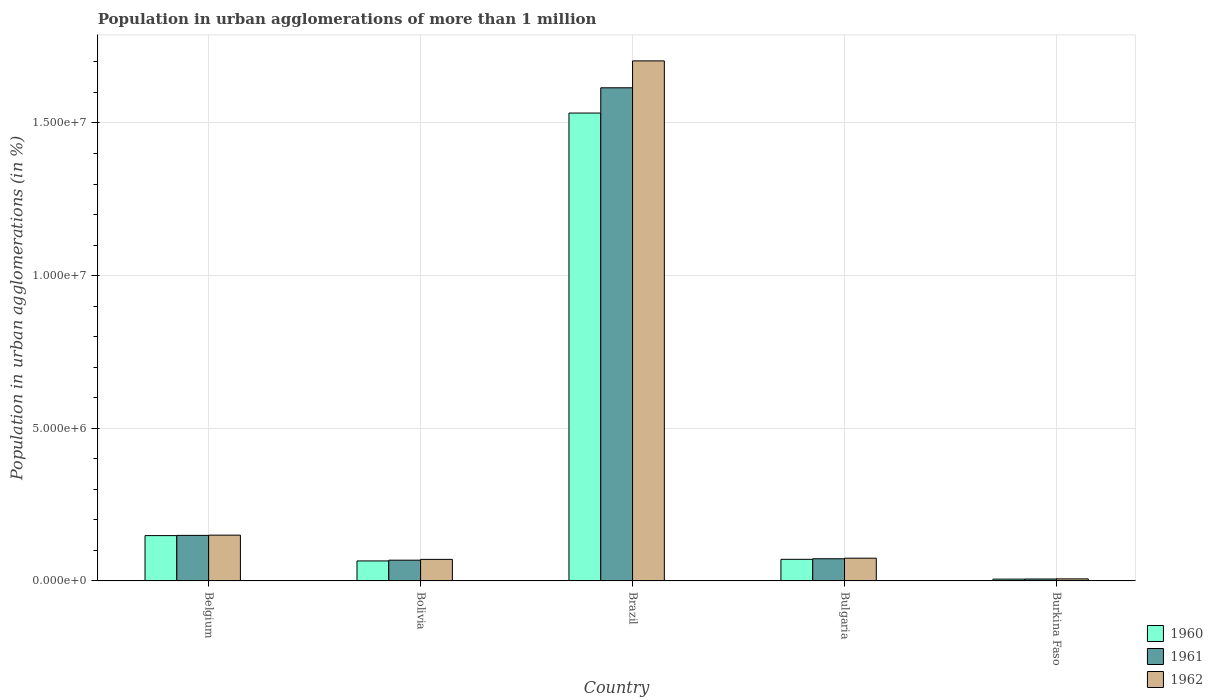How many groups of bars are there?
Ensure brevity in your answer.  5. How many bars are there on the 2nd tick from the right?
Your response must be concise. 3. What is the label of the 2nd group of bars from the left?
Keep it short and to the point. Bolivia. What is the population in urban agglomerations in 1962 in Bolivia?
Keep it short and to the point. 7.06e+05. Across all countries, what is the maximum population in urban agglomerations in 1962?
Offer a terse response. 1.70e+07. Across all countries, what is the minimum population in urban agglomerations in 1961?
Offer a terse response. 6.31e+04. In which country was the population in urban agglomerations in 1960 maximum?
Your response must be concise. Brazil. In which country was the population in urban agglomerations in 1961 minimum?
Provide a succinct answer. Burkina Faso. What is the total population in urban agglomerations in 1961 in the graph?
Offer a very short reply. 1.91e+07. What is the difference between the population in urban agglomerations in 1961 in Belgium and that in Bolivia?
Ensure brevity in your answer.  8.12e+05. What is the difference between the population in urban agglomerations in 1962 in Burkina Faso and the population in urban agglomerations in 1961 in Brazil?
Offer a terse response. -1.61e+07. What is the average population in urban agglomerations in 1960 per country?
Offer a terse response. 3.65e+06. What is the difference between the population in urban agglomerations of/in 1962 and population in urban agglomerations of/in 1960 in Brazil?
Your answer should be compact. 1.71e+06. In how many countries, is the population in urban agglomerations in 1961 greater than 10000000 %?
Provide a short and direct response. 1. What is the ratio of the population in urban agglomerations in 1960 in Belgium to that in Bulgaria?
Provide a short and direct response. 2.1. Is the difference between the population in urban agglomerations in 1962 in Belgium and Bulgaria greater than the difference between the population in urban agglomerations in 1960 in Belgium and Bulgaria?
Provide a succinct answer. No. What is the difference between the highest and the second highest population in urban agglomerations in 1961?
Make the answer very short. -1.54e+07. What is the difference between the highest and the lowest population in urban agglomerations in 1962?
Make the answer very short. 1.70e+07. Is the sum of the population in urban agglomerations in 1960 in Brazil and Bulgaria greater than the maximum population in urban agglomerations in 1962 across all countries?
Offer a terse response. No. How many bars are there?
Your answer should be very brief. 15. Are all the bars in the graph horizontal?
Your answer should be very brief. No. What is the difference between two consecutive major ticks on the Y-axis?
Your answer should be very brief. 5.00e+06. Does the graph contain any zero values?
Give a very brief answer. No. Does the graph contain grids?
Your response must be concise. Yes. What is the title of the graph?
Your answer should be compact. Population in urban agglomerations of more than 1 million. Does "1993" appear as one of the legend labels in the graph?
Your answer should be compact. No. What is the label or title of the X-axis?
Make the answer very short. Country. What is the label or title of the Y-axis?
Offer a terse response. Population in urban agglomerations (in %). What is the Population in urban agglomerations (in %) of 1960 in Belgium?
Ensure brevity in your answer.  1.48e+06. What is the Population in urban agglomerations (in %) in 1961 in Belgium?
Your answer should be very brief. 1.49e+06. What is the Population in urban agglomerations (in %) in 1962 in Belgium?
Provide a short and direct response. 1.50e+06. What is the Population in urban agglomerations (in %) in 1960 in Bolivia?
Keep it short and to the point. 6.55e+05. What is the Population in urban agglomerations (in %) in 1961 in Bolivia?
Your response must be concise. 6.80e+05. What is the Population in urban agglomerations (in %) in 1962 in Bolivia?
Ensure brevity in your answer.  7.06e+05. What is the Population in urban agglomerations (in %) in 1960 in Brazil?
Your response must be concise. 1.53e+07. What is the Population in urban agglomerations (in %) in 1961 in Brazil?
Offer a terse response. 1.62e+07. What is the Population in urban agglomerations (in %) in 1962 in Brazil?
Keep it short and to the point. 1.70e+07. What is the Population in urban agglomerations (in %) in 1960 in Bulgaria?
Keep it short and to the point. 7.08e+05. What is the Population in urban agglomerations (in %) in 1961 in Bulgaria?
Provide a short and direct response. 7.27e+05. What is the Population in urban agglomerations (in %) in 1962 in Bulgaria?
Provide a short and direct response. 7.46e+05. What is the Population in urban agglomerations (in %) in 1960 in Burkina Faso?
Provide a succinct answer. 5.91e+04. What is the Population in urban agglomerations (in %) in 1961 in Burkina Faso?
Your answer should be compact. 6.31e+04. What is the Population in urban agglomerations (in %) of 1962 in Burkina Faso?
Offer a terse response. 6.73e+04. Across all countries, what is the maximum Population in urban agglomerations (in %) in 1960?
Offer a terse response. 1.53e+07. Across all countries, what is the maximum Population in urban agglomerations (in %) of 1961?
Make the answer very short. 1.62e+07. Across all countries, what is the maximum Population in urban agglomerations (in %) in 1962?
Provide a short and direct response. 1.70e+07. Across all countries, what is the minimum Population in urban agglomerations (in %) in 1960?
Give a very brief answer. 5.91e+04. Across all countries, what is the minimum Population in urban agglomerations (in %) of 1961?
Offer a very short reply. 6.31e+04. Across all countries, what is the minimum Population in urban agglomerations (in %) in 1962?
Ensure brevity in your answer.  6.73e+04. What is the total Population in urban agglomerations (in %) in 1960 in the graph?
Ensure brevity in your answer.  1.82e+07. What is the total Population in urban agglomerations (in %) of 1961 in the graph?
Ensure brevity in your answer.  1.91e+07. What is the total Population in urban agglomerations (in %) in 1962 in the graph?
Keep it short and to the point. 2.01e+07. What is the difference between the Population in urban agglomerations (in %) of 1960 in Belgium and that in Bolivia?
Keep it short and to the point. 8.29e+05. What is the difference between the Population in urban agglomerations (in %) of 1961 in Belgium and that in Bolivia?
Offer a very short reply. 8.12e+05. What is the difference between the Population in urban agglomerations (in %) in 1962 in Belgium and that in Bolivia?
Your answer should be compact. 7.94e+05. What is the difference between the Population in urban agglomerations (in %) in 1960 in Belgium and that in Brazil?
Offer a very short reply. -1.38e+07. What is the difference between the Population in urban agglomerations (in %) in 1961 in Belgium and that in Brazil?
Provide a succinct answer. -1.47e+07. What is the difference between the Population in urban agglomerations (in %) in 1962 in Belgium and that in Brazil?
Give a very brief answer. -1.55e+07. What is the difference between the Population in urban agglomerations (in %) of 1960 in Belgium and that in Bulgaria?
Your answer should be compact. 7.77e+05. What is the difference between the Population in urban agglomerations (in %) in 1961 in Belgium and that in Bulgaria?
Your answer should be compact. 7.65e+05. What is the difference between the Population in urban agglomerations (in %) in 1962 in Belgium and that in Bulgaria?
Keep it short and to the point. 7.54e+05. What is the difference between the Population in urban agglomerations (in %) in 1960 in Belgium and that in Burkina Faso?
Keep it short and to the point. 1.43e+06. What is the difference between the Population in urban agglomerations (in %) of 1961 in Belgium and that in Burkina Faso?
Keep it short and to the point. 1.43e+06. What is the difference between the Population in urban agglomerations (in %) of 1962 in Belgium and that in Burkina Faso?
Provide a succinct answer. 1.43e+06. What is the difference between the Population in urban agglomerations (in %) of 1960 in Bolivia and that in Brazil?
Provide a succinct answer. -1.47e+07. What is the difference between the Population in urban agglomerations (in %) of 1961 in Bolivia and that in Brazil?
Your answer should be very brief. -1.55e+07. What is the difference between the Population in urban agglomerations (in %) of 1962 in Bolivia and that in Brazil?
Your answer should be compact. -1.63e+07. What is the difference between the Population in urban agglomerations (in %) of 1960 in Bolivia and that in Bulgaria?
Ensure brevity in your answer.  -5.27e+04. What is the difference between the Population in urban agglomerations (in %) in 1961 in Bolivia and that in Bulgaria?
Your answer should be very brief. -4.64e+04. What is the difference between the Population in urban agglomerations (in %) in 1962 in Bolivia and that in Bulgaria?
Provide a succinct answer. -3.95e+04. What is the difference between the Population in urban agglomerations (in %) in 1960 in Bolivia and that in Burkina Faso?
Provide a succinct answer. 5.96e+05. What is the difference between the Population in urban agglomerations (in %) of 1961 in Bolivia and that in Burkina Faso?
Offer a very short reply. 6.17e+05. What is the difference between the Population in urban agglomerations (in %) in 1962 in Bolivia and that in Burkina Faso?
Give a very brief answer. 6.39e+05. What is the difference between the Population in urban agglomerations (in %) in 1960 in Brazil and that in Bulgaria?
Ensure brevity in your answer.  1.46e+07. What is the difference between the Population in urban agglomerations (in %) in 1961 in Brazil and that in Bulgaria?
Offer a very short reply. 1.54e+07. What is the difference between the Population in urban agglomerations (in %) of 1962 in Brazil and that in Bulgaria?
Your answer should be compact. 1.63e+07. What is the difference between the Population in urban agglomerations (in %) in 1960 in Brazil and that in Burkina Faso?
Provide a succinct answer. 1.53e+07. What is the difference between the Population in urban agglomerations (in %) in 1961 in Brazil and that in Burkina Faso?
Your response must be concise. 1.61e+07. What is the difference between the Population in urban agglomerations (in %) in 1962 in Brazil and that in Burkina Faso?
Offer a very short reply. 1.70e+07. What is the difference between the Population in urban agglomerations (in %) in 1960 in Bulgaria and that in Burkina Faso?
Your answer should be very brief. 6.49e+05. What is the difference between the Population in urban agglomerations (in %) in 1961 in Bulgaria and that in Burkina Faso?
Your answer should be very brief. 6.63e+05. What is the difference between the Population in urban agglomerations (in %) of 1962 in Bulgaria and that in Burkina Faso?
Your answer should be very brief. 6.78e+05. What is the difference between the Population in urban agglomerations (in %) of 1960 in Belgium and the Population in urban agglomerations (in %) of 1961 in Bolivia?
Give a very brief answer. 8.05e+05. What is the difference between the Population in urban agglomerations (in %) of 1960 in Belgium and the Population in urban agglomerations (in %) of 1962 in Bolivia?
Keep it short and to the point. 7.79e+05. What is the difference between the Population in urban agglomerations (in %) in 1961 in Belgium and the Population in urban agglomerations (in %) in 1962 in Bolivia?
Provide a short and direct response. 7.86e+05. What is the difference between the Population in urban agglomerations (in %) of 1960 in Belgium and the Population in urban agglomerations (in %) of 1961 in Brazil?
Make the answer very short. -1.47e+07. What is the difference between the Population in urban agglomerations (in %) in 1960 in Belgium and the Population in urban agglomerations (in %) in 1962 in Brazil?
Keep it short and to the point. -1.55e+07. What is the difference between the Population in urban agglomerations (in %) of 1961 in Belgium and the Population in urban agglomerations (in %) of 1962 in Brazil?
Ensure brevity in your answer.  -1.55e+07. What is the difference between the Population in urban agglomerations (in %) in 1960 in Belgium and the Population in urban agglomerations (in %) in 1961 in Bulgaria?
Your answer should be compact. 7.58e+05. What is the difference between the Population in urban agglomerations (in %) in 1960 in Belgium and the Population in urban agglomerations (in %) in 1962 in Bulgaria?
Provide a succinct answer. 7.39e+05. What is the difference between the Population in urban agglomerations (in %) of 1961 in Belgium and the Population in urban agglomerations (in %) of 1962 in Bulgaria?
Give a very brief answer. 7.46e+05. What is the difference between the Population in urban agglomerations (in %) of 1960 in Belgium and the Population in urban agglomerations (in %) of 1961 in Burkina Faso?
Give a very brief answer. 1.42e+06. What is the difference between the Population in urban agglomerations (in %) of 1960 in Belgium and the Population in urban agglomerations (in %) of 1962 in Burkina Faso?
Ensure brevity in your answer.  1.42e+06. What is the difference between the Population in urban agglomerations (in %) of 1961 in Belgium and the Population in urban agglomerations (in %) of 1962 in Burkina Faso?
Your answer should be very brief. 1.42e+06. What is the difference between the Population in urban agglomerations (in %) in 1960 in Bolivia and the Population in urban agglomerations (in %) in 1961 in Brazil?
Make the answer very short. -1.55e+07. What is the difference between the Population in urban agglomerations (in %) of 1960 in Bolivia and the Population in urban agglomerations (in %) of 1962 in Brazil?
Make the answer very short. -1.64e+07. What is the difference between the Population in urban agglomerations (in %) of 1961 in Bolivia and the Population in urban agglomerations (in %) of 1962 in Brazil?
Offer a very short reply. -1.64e+07. What is the difference between the Population in urban agglomerations (in %) of 1960 in Bolivia and the Population in urban agglomerations (in %) of 1961 in Bulgaria?
Make the answer very short. -7.11e+04. What is the difference between the Population in urban agglomerations (in %) in 1960 in Bolivia and the Population in urban agglomerations (in %) in 1962 in Bulgaria?
Offer a terse response. -9.02e+04. What is the difference between the Population in urban agglomerations (in %) in 1961 in Bolivia and the Population in urban agglomerations (in %) in 1962 in Bulgaria?
Ensure brevity in your answer.  -6.54e+04. What is the difference between the Population in urban agglomerations (in %) in 1960 in Bolivia and the Population in urban agglomerations (in %) in 1961 in Burkina Faso?
Offer a very short reply. 5.92e+05. What is the difference between the Population in urban agglomerations (in %) of 1960 in Bolivia and the Population in urban agglomerations (in %) of 1962 in Burkina Faso?
Keep it short and to the point. 5.88e+05. What is the difference between the Population in urban agglomerations (in %) in 1961 in Bolivia and the Population in urban agglomerations (in %) in 1962 in Burkina Faso?
Your response must be concise. 6.13e+05. What is the difference between the Population in urban agglomerations (in %) in 1960 in Brazil and the Population in urban agglomerations (in %) in 1961 in Bulgaria?
Make the answer very short. 1.46e+07. What is the difference between the Population in urban agglomerations (in %) of 1960 in Brazil and the Population in urban agglomerations (in %) of 1962 in Bulgaria?
Offer a terse response. 1.46e+07. What is the difference between the Population in urban agglomerations (in %) in 1961 in Brazil and the Population in urban agglomerations (in %) in 1962 in Bulgaria?
Ensure brevity in your answer.  1.54e+07. What is the difference between the Population in urban agglomerations (in %) of 1960 in Brazil and the Population in urban agglomerations (in %) of 1961 in Burkina Faso?
Ensure brevity in your answer.  1.53e+07. What is the difference between the Population in urban agglomerations (in %) of 1960 in Brazil and the Population in urban agglomerations (in %) of 1962 in Burkina Faso?
Keep it short and to the point. 1.53e+07. What is the difference between the Population in urban agglomerations (in %) in 1961 in Brazil and the Population in urban agglomerations (in %) in 1962 in Burkina Faso?
Make the answer very short. 1.61e+07. What is the difference between the Population in urban agglomerations (in %) in 1960 in Bulgaria and the Population in urban agglomerations (in %) in 1961 in Burkina Faso?
Your answer should be compact. 6.45e+05. What is the difference between the Population in urban agglomerations (in %) of 1960 in Bulgaria and the Population in urban agglomerations (in %) of 1962 in Burkina Faso?
Provide a succinct answer. 6.41e+05. What is the difference between the Population in urban agglomerations (in %) of 1961 in Bulgaria and the Population in urban agglomerations (in %) of 1962 in Burkina Faso?
Provide a short and direct response. 6.59e+05. What is the average Population in urban agglomerations (in %) of 1960 per country?
Provide a short and direct response. 3.65e+06. What is the average Population in urban agglomerations (in %) in 1961 per country?
Make the answer very short. 3.82e+06. What is the average Population in urban agglomerations (in %) of 1962 per country?
Give a very brief answer. 4.01e+06. What is the difference between the Population in urban agglomerations (in %) in 1960 and Population in urban agglomerations (in %) in 1961 in Belgium?
Provide a short and direct response. -7177. What is the difference between the Population in urban agglomerations (in %) in 1960 and Population in urban agglomerations (in %) in 1962 in Belgium?
Make the answer very short. -1.49e+04. What is the difference between the Population in urban agglomerations (in %) of 1961 and Population in urban agglomerations (in %) of 1962 in Belgium?
Provide a succinct answer. -7758. What is the difference between the Population in urban agglomerations (in %) in 1960 and Population in urban agglomerations (in %) in 1961 in Bolivia?
Provide a succinct answer. -2.48e+04. What is the difference between the Population in urban agglomerations (in %) in 1960 and Population in urban agglomerations (in %) in 1962 in Bolivia?
Your answer should be very brief. -5.06e+04. What is the difference between the Population in urban agglomerations (in %) of 1961 and Population in urban agglomerations (in %) of 1962 in Bolivia?
Your answer should be compact. -2.58e+04. What is the difference between the Population in urban agglomerations (in %) of 1960 and Population in urban agglomerations (in %) of 1961 in Brazil?
Give a very brief answer. -8.28e+05. What is the difference between the Population in urban agglomerations (in %) of 1960 and Population in urban agglomerations (in %) of 1962 in Brazil?
Offer a very short reply. -1.71e+06. What is the difference between the Population in urban agglomerations (in %) of 1961 and Population in urban agglomerations (in %) of 1962 in Brazil?
Offer a very short reply. -8.81e+05. What is the difference between the Population in urban agglomerations (in %) of 1960 and Population in urban agglomerations (in %) of 1961 in Bulgaria?
Provide a succinct answer. -1.85e+04. What is the difference between the Population in urban agglomerations (in %) in 1960 and Population in urban agglomerations (in %) in 1962 in Bulgaria?
Give a very brief answer. -3.75e+04. What is the difference between the Population in urban agglomerations (in %) in 1961 and Population in urban agglomerations (in %) in 1962 in Bulgaria?
Give a very brief answer. -1.90e+04. What is the difference between the Population in urban agglomerations (in %) in 1960 and Population in urban agglomerations (in %) in 1961 in Burkina Faso?
Your answer should be compact. -3964. What is the difference between the Population in urban agglomerations (in %) in 1960 and Population in urban agglomerations (in %) in 1962 in Burkina Faso?
Your response must be concise. -8199. What is the difference between the Population in urban agglomerations (in %) of 1961 and Population in urban agglomerations (in %) of 1962 in Burkina Faso?
Offer a terse response. -4235. What is the ratio of the Population in urban agglomerations (in %) in 1960 in Belgium to that in Bolivia?
Make the answer very short. 2.27. What is the ratio of the Population in urban agglomerations (in %) in 1961 in Belgium to that in Bolivia?
Your response must be concise. 2.19. What is the ratio of the Population in urban agglomerations (in %) of 1962 in Belgium to that in Bolivia?
Make the answer very short. 2.12. What is the ratio of the Population in urban agglomerations (in %) of 1960 in Belgium to that in Brazil?
Your answer should be very brief. 0.1. What is the ratio of the Population in urban agglomerations (in %) of 1961 in Belgium to that in Brazil?
Make the answer very short. 0.09. What is the ratio of the Population in urban agglomerations (in %) in 1962 in Belgium to that in Brazil?
Your answer should be very brief. 0.09. What is the ratio of the Population in urban agglomerations (in %) of 1960 in Belgium to that in Bulgaria?
Keep it short and to the point. 2.1. What is the ratio of the Population in urban agglomerations (in %) in 1961 in Belgium to that in Bulgaria?
Make the answer very short. 2.05. What is the ratio of the Population in urban agglomerations (in %) of 1962 in Belgium to that in Bulgaria?
Your response must be concise. 2.01. What is the ratio of the Population in urban agglomerations (in %) of 1960 in Belgium to that in Burkina Faso?
Your answer should be compact. 25.11. What is the ratio of the Population in urban agglomerations (in %) in 1961 in Belgium to that in Burkina Faso?
Offer a terse response. 23.65. What is the ratio of the Population in urban agglomerations (in %) in 1962 in Belgium to that in Burkina Faso?
Your answer should be very brief. 22.27. What is the ratio of the Population in urban agglomerations (in %) of 1960 in Bolivia to that in Brazil?
Keep it short and to the point. 0.04. What is the ratio of the Population in urban agglomerations (in %) of 1961 in Bolivia to that in Brazil?
Your answer should be very brief. 0.04. What is the ratio of the Population in urban agglomerations (in %) in 1962 in Bolivia to that in Brazil?
Offer a very short reply. 0.04. What is the ratio of the Population in urban agglomerations (in %) of 1960 in Bolivia to that in Bulgaria?
Make the answer very short. 0.93. What is the ratio of the Population in urban agglomerations (in %) in 1961 in Bolivia to that in Bulgaria?
Provide a succinct answer. 0.94. What is the ratio of the Population in urban agglomerations (in %) in 1962 in Bolivia to that in Bulgaria?
Your answer should be very brief. 0.95. What is the ratio of the Population in urban agglomerations (in %) in 1960 in Bolivia to that in Burkina Faso?
Keep it short and to the point. 11.09. What is the ratio of the Population in urban agglomerations (in %) of 1961 in Bolivia to that in Burkina Faso?
Give a very brief answer. 10.78. What is the ratio of the Population in urban agglomerations (in %) of 1962 in Bolivia to that in Burkina Faso?
Keep it short and to the point. 10.49. What is the ratio of the Population in urban agglomerations (in %) in 1960 in Brazil to that in Bulgaria?
Ensure brevity in your answer.  21.64. What is the ratio of the Population in urban agglomerations (in %) of 1961 in Brazil to that in Bulgaria?
Keep it short and to the point. 22.23. What is the ratio of the Population in urban agglomerations (in %) of 1962 in Brazil to that in Bulgaria?
Offer a terse response. 22.85. What is the ratio of the Population in urban agglomerations (in %) of 1960 in Brazil to that in Burkina Faso?
Your response must be concise. 259.17. What is the ratio of the Population in urban agglomerations (in %) of 1961 in Brazil to that in Burkina Faso?
Keep it short and to the point. 256.01. What is the ratio of the Population in urban agglomerations (in %) of 1962 in Brazil to that in Burkina Faso?
Ensure brevity in your answer.  253. What is the ratio of the Population in urban agglomerations (in %) in 1960 in Bulgaria to that in Burkina Faso?
Give a very brief answer. 11.98. What is the ratio of the Population in urban agglomerations (in %) in 1961 in Bulgaria to that in Burkina Faso?
Give a very brief answer. 11.52. What is the ratio of the Population in urban agglomerations (in %) in 1962 in Bulgaria to that in Burkina Faso?
Provide a succinct answer. 11.07. What is the difference between the highest and the second highest Population in urban agglomerations (in %) in 1960?
Make the answer very short. 1.38e+07. What is the difference between the highest and the second highest Population in urban agglomerations (in %) in 1961?
Your response must be concise. 1.47e+07. What is the difference between the highest and the second highest Population in urban agglomerations (in %) in 1962?
Give a very brief answer. 1.55e+07. What is the difference between the highest and the lowest Population in urban agglomerations (in %) of 1960?
Your response must be concise. 1.53e+07. What is the difference between the highest and the lowest Population in urban agglomerations (in %) in 1961?
Offer a terse response. 1.61e+07. What is the difference between the highest and the lowest Population in urban agglomerations (in %) of 1962?
Give a very brief answer. 1.70e+07. 